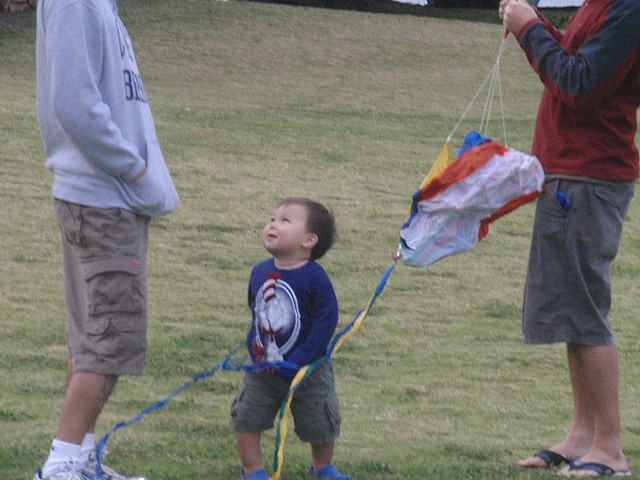Describe the objects in this image and their specific colors. I can see people in black, gray, and maroon tones, people in black, gray, and darkgray tones, people in black, gray, navy, and darkgray tones, and kite in black, gray, darkgray, and brown tones in this image. 